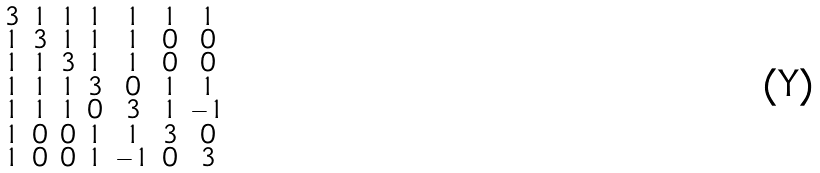<formula> <loc_0><loc_0><loc_500><loc_500>\begin{smallmatrix} 3 & 1 & 1 & 1 & 1 & 1 & 1 \\ 1 & 3 & 1 & 1 & 1 & 0 & 0 \\ 1 & 1 & 3 & 1 & 1 & 0 & 0 \\ 1 & 1 & 1 & 3 & 0 & 1 & 1 \\ 1 & 1 & 1 & 0 & 3 & 1 & - 1 \\ 1 & 0 & 0 & 1 & 1 & 3 & 0 \\ 1 & 0 & 0 & 1 & - 1 & 0 & 3 \end{smallmatrix}</formula> 